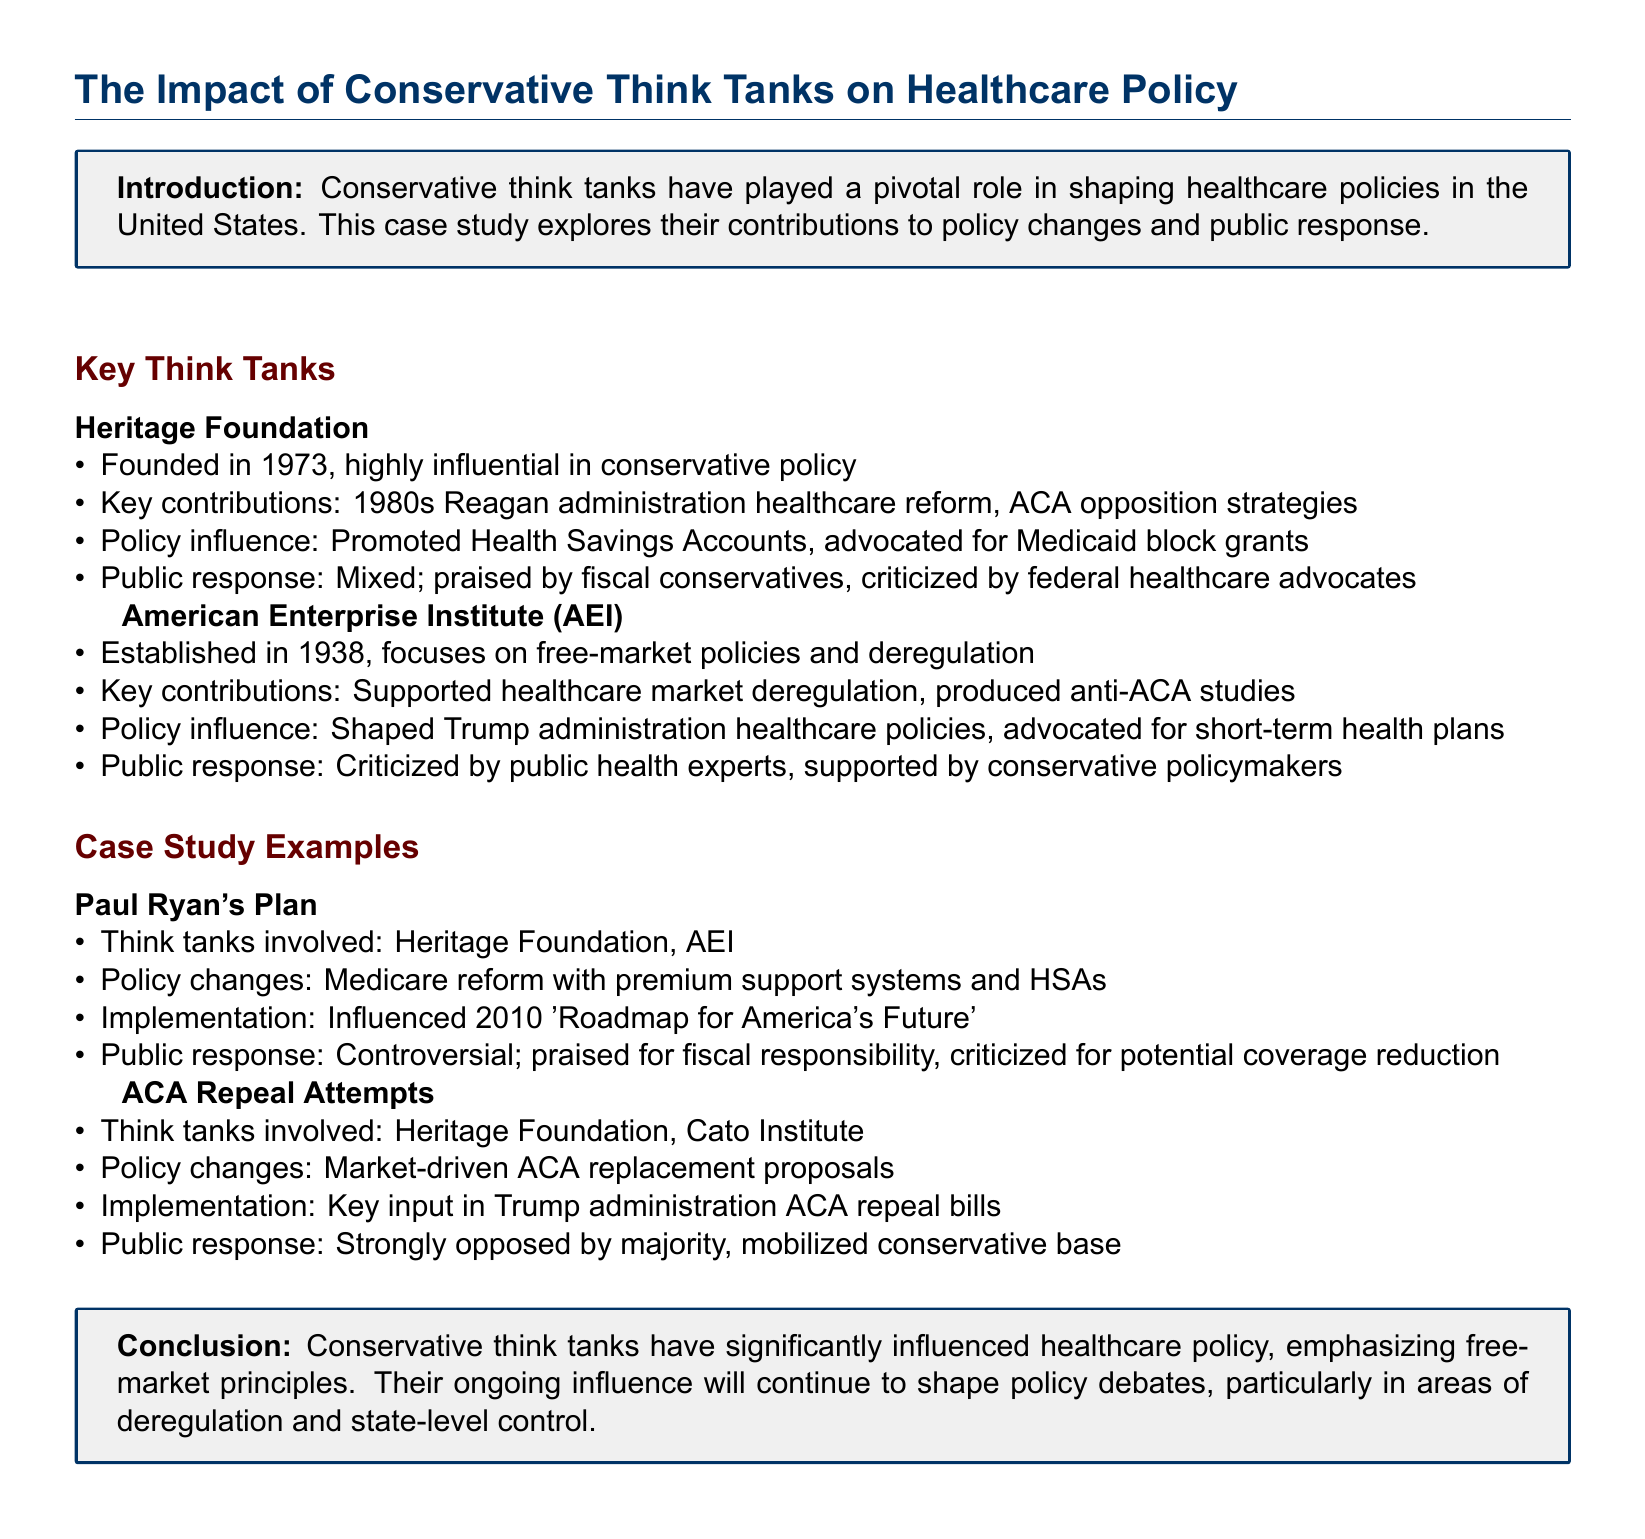What are the names of two key conservative think tanks mentioned? The document lists Heritage Foundation and American Enterprise Institute as two key conservative think tanks.
Answer: Heritage Foundation, American Enterprise Institute When was the Heritage Foundation founded? The founding year of the Heritage Foundation is specified in the document.
Answer: 1973 What healthcare policy did the Heritage Foundation promote? The document indicates that the Heritage Foundation promoted Health Savings Accounts among other policies.
Answer: Health Savings Accounts What was a key policy change in Paul Ryan's Plan? The document discusses Medicare reform as a significant aspect of Paul Ryan's Plan.
Answer: Medicare reform Which administration's healthcare policies were shaped by AEI? The document states AEI shaped the healthcare policies of the Trump administration.
Answer: Trump administration What type of healthcare plans did AEI advocate for? AEI is noted for advocating short-term health plans according to the document.
Answer: Short-term health plans How was the public response to ACA repeal attempts characterized? The document notes that the public response was strongly opposed by the majority regarding ACA repeal attempts.
Answer: Strongly opposed by majority What was the conclusion about the influence of conservative think tanks? The conclusion states that conservative think tanks have significantly influenced healthcare policy and will continue to do so.
Answer: Significantly influenced healthcare policy Which think tanks were involved in the ACA repeal proposals? The document mentions that Heritage Foundation and Cato Institute were involved in ACA repeal proposals.
Answer: Heritage Foundation, Cato Institute 